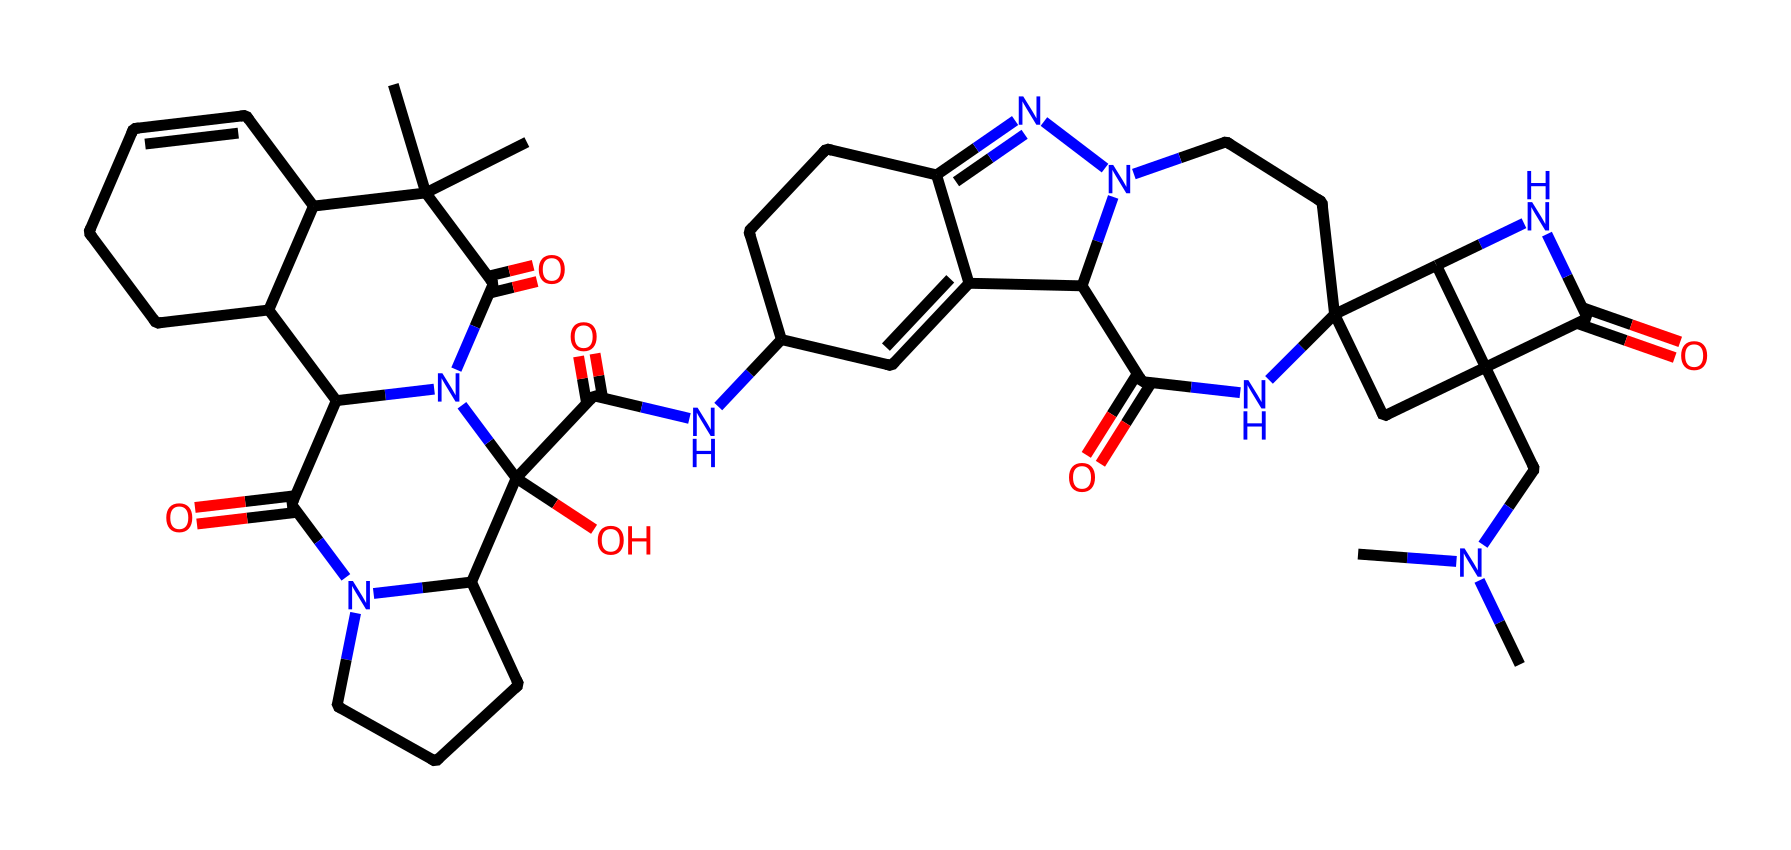What is the molecular formula of ergotamine? To determine the molecular formula, we can analyze the SMILES representation. By counting each type of atom represented in the structure, we can derive the formula. In the case of ergotamine, there are 25 carbon atoms, 34 hydrogen atoms, 5 nitrogen atoms, and 5 oxygen atoms. Therefore, the molecular formula is C25H34N5O5.
Answer: C25H34N5O5 How many nitrogen atoms are present in ergotamine? The SMILES representation contains multiple nitrogen atoms indicated by the presence of 'N' in the structure. By carefully inspecting the SMILES string, we can identify a total of 5 nitrogen atoms.
Answer: 5 What type of functional groups are present in ergotamine? To identify functional groups, we can analyze the structure indicated in the SMILES string. Common functional groups such as amides, which contain the nitrogen bonded to a carbonyl group, can be seen in multiple places. The presence of hydroxyl (-OH) groups also suggests its classification as an alkaloid.
Answer: amide, hydroxyl What type of ring structures are in ergotamine? By examining the SMILES string closely, we can identify that ergotamine contains several ring structures: there are fused cyclopentane and cyclohexane rings, and various nitrogen-containing rings. These structure types indicate a complex polycyclic nature typical in alkaloids.
Answer: polycyclic What is the characteristic property of ergotamine due to its nitrogen content? Ergotamine, an alkaloid, derives its characteristic properties from the nitrogen atoms. The presence of nitrogen in its structure typically contributes to its psychoactive effects and medicinal properties, particularly in migraine treatments. Thus, the chemical's alkaloid classification is significant.
Answer: psychoactive properties What is the total count of carbon atoms in ergotamine? To count the carbon atoms, we analyze the SMILES string for 'C' symbols, representing carbon. By summing these occurrences, we find that there are 25 carbon atoms in the structure of ergotamine.
Answer: 25 